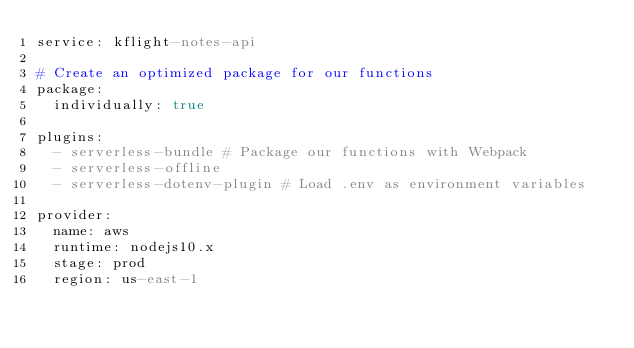Convert code to text. <code><loc_0><loc_0><loc_500><loc_500><_YAML_>service: kflight-notes-api

# Create an optimized package for our functions
package:
  individually: true

plugins:
  - serverless-bundle # Package our functions with Webpack
  - serverless-offline
  - serverless-dotenv-plugin # Load .env as environment variables

provider:
  name: aws
  runtime: nodejs10.x
  stage: prod
  region: us-east-1
</code> 